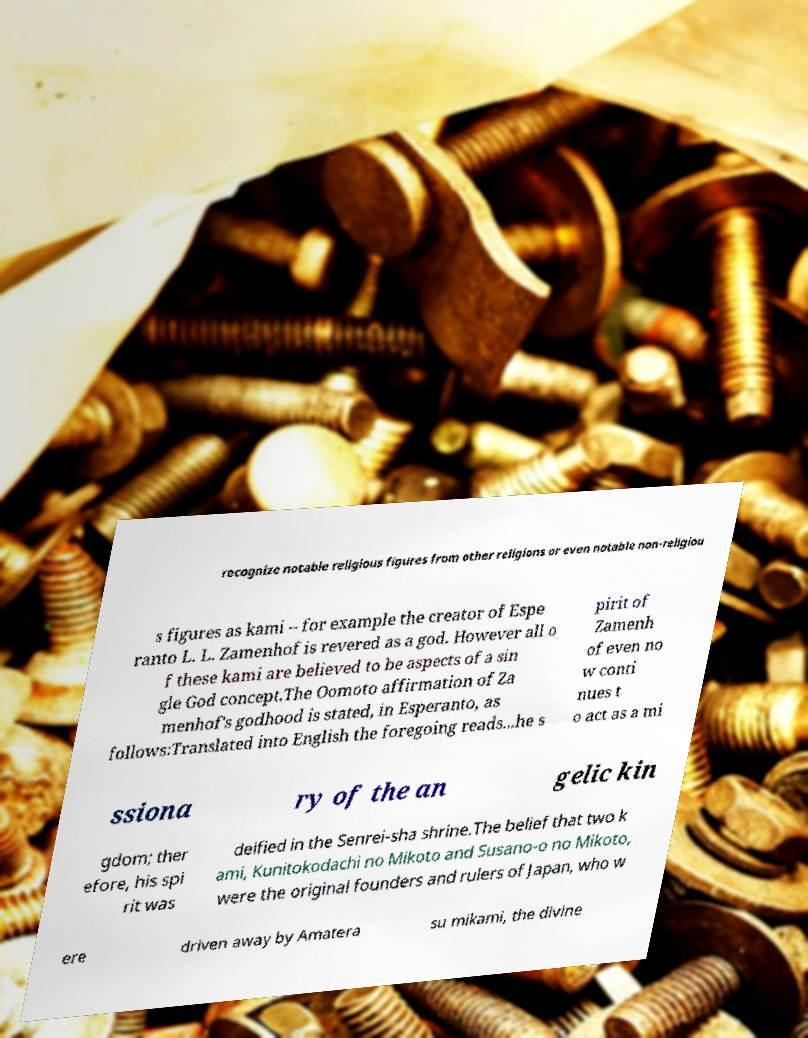What messages or text are displayed in this image? I need them in a readable, typed format. recognize notable religious figures from other religions or even notable non-religiou s figures as kami – for example the creator of Espe ranto L. L. Zamenhof is revered as a god. However all o f these kami are believed to be aspects of a sin gle God concept.The Oomoto affirmation of Za menhof's godhood is stated, in Esperanto, as follows:Translated into English the foregoing reads...he s pirit of Zamenh of even no w conti nues t o act as a mi ssiona ry of the an gelic kin gdom; ther efore, his spi rit was deified in the Senrei-sha shrine.The belief that two k ami, Kunitokodachi no Mikoto and Susano-o no Mikoto, were the original founders and rulers of Japan, who w ere driven away by Amatera su mikami, the divine 